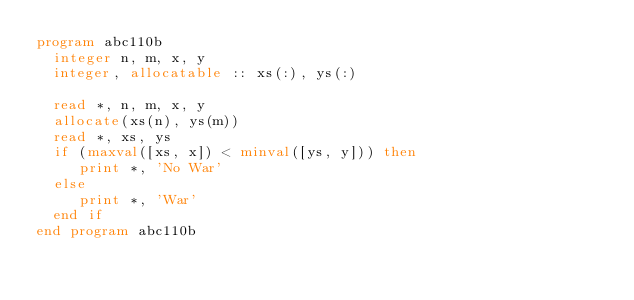Convert code to text. <code><loc_0><loc_0><loc_500><loc_500><_FORTRAN_>program abc110b
  integer n, m, x, y
  integer, allocatable :: xs(:), ys(:)

  read *, n, m, x, y
  allocate(xs(n), ys(m))
  read *, xs, ys
  if (maxval([xs, x]) < minval([ys, y])) then
     print *, 'No War'
  else
     print *, 'War'
  end if
end program abc110b
</code> 